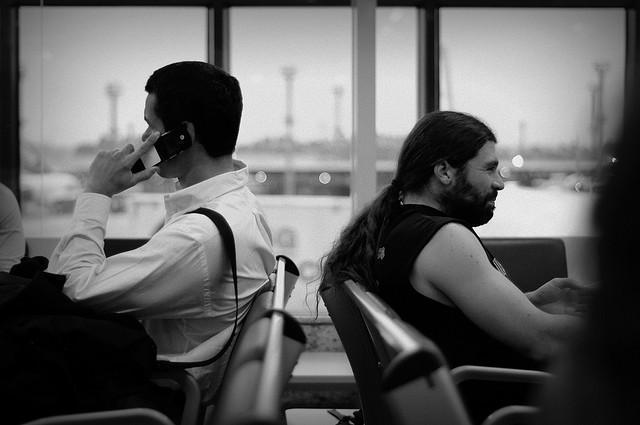How many people are there?
Give a very brief answer. 2. How many benches are there?
Give a very brief answer. 2. How many chairs are there?
Give a very brief answer. 2. How many handbags are visible?
Give a very brief answer. 2. 